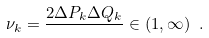Convert formula to latex. <formula><loc_0><loc_0><loc_500><loc_500>\nu _ { k } = \frac { 2 \Delta P _ { k } \Delta Q _ { k } } { } \in ( 1 , \infty ) \ .</formula> 